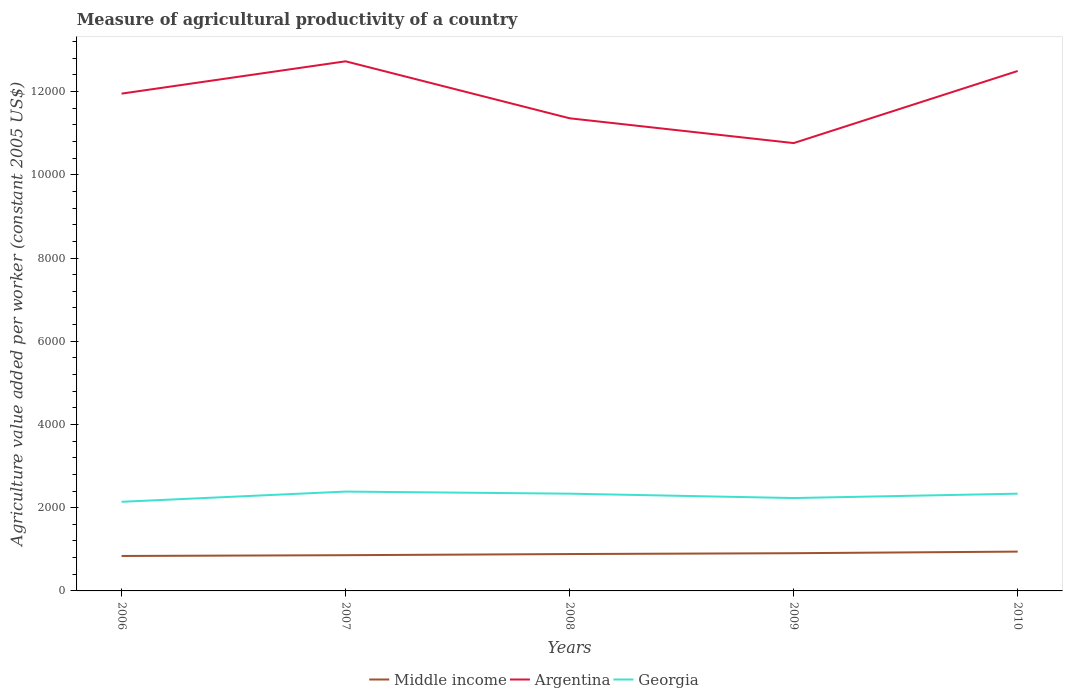How many different coloured lines are there?
Provide a succinct answer. 3. Across all years, what is the maximum measure of agricultural productivity in Argentina?
Give a very brief answer. 1.08e+04. What is the total measure of agricultural productivity in Middle income in the graph?
Offer a terse response. -58.76. What is the difference between the highest and the second highest measure of agricultural productivity in Middle income?
Ensure brevity in your answer.  104.96. How many lines are there?
Your answer should be very brief. 3. How many years are there in the graph?
Provide a short and direct response. 5. What is the difference between two consecutive major ticks on the Y-axis?
Provide a short and direct response. 2000. What is the title of the graph?
Your answer should be compact. Measure of agricultural productivity of a country. What is the label or title of the Y-axis?
Offer a terse response. Agriculture value added per worker (constant 2005 US$). What is the Agriculture value added per worker (constant 2005 US$) in Middle income in 2006?
Your response must be concise. 839.85. What is the Agriculture value added per worker (constant 2005 US$) in Argentina in 2006?
Provide a succinct answer. 1.20e+04. What is the Agriculture value added per worker (constant 2005 US$) of Georgia in 2006?
Offer a very short reply. 2142.02. What is the Agriculture value added per worker (constant 2005 US$) of Middle income in 2007?
Offer a terse response. 858.89. What is the Agriculture value added per worker (constant 2005 US$) in Argentina in 2007?
Keep it short and to the point. 1.27e+04. What is the Agriculture value added per worker (constant 2005 US$) in Georgia in 2007?
Make the answer very short. 2387.6. What is the Agriculture value added per worker (constant 2005 US$) of Middle income in 2008?
Offer a very short reply. 886.05. What is the Agriculture value added per worker (constant 2005 US$) in Argentina in 2008?
Your response must be concise. 1.14e+04. What is the Agriculture value added per worker (constant 2005 US$) of Georgia in 2008?
Provide a succinct answer. 2337.08. What is the Agriculture value added per worker (constant 2005 US$) of Middle income in 2009?
Offer a terse response. 906.34. What is the Agriculture value added per worker (constant 2005 US$) of Argentina in 2009?
Give a very brief answer. 1.08e+04. What is the Agriculture value added per worker (constant 2005 US$) of Georgia in 2009?
Provide a short and direct response. 2232.16. What is the Agriculture value added per worker (constant 2005 US$) of Middle income in 2010?
Give a very brief answer. 944.82. What is the Agriculture value added per worker (constant 2005 US$) of Argentina in 2010?
Your answer should be compact. 1.25e+04. What is the Agriculture value added per worker (constant 2005 US$) in Georgia in 2010?
Ensure brevity in your answer.  2337.06. Across all years, what is the maximum Agriculture value added per worker (constant 2005 US$) in Middle income?
Provide a short and direct response. 944.82. Across all years, what is the maximum Agriculture value added per worker (constant 2005 US$) of Argentina?
Provide a succinct answer. 1.27e+04. Across all years, what is the maximum Agriculture value added per worker (constant 2005 US$) in Georgia?
Give a very brief answer. 2387.6. Across all years, what is the minimum Agriculture value added per worker (constant 2005 US$) in Middle income?
Keep it short and to the point. 839.85. Across all years, what is the minimum Agriculture value added per worker (constant 2005 US$) in Argentina?
Ensure brevity in your answer.  1.08e+04. Across all years, what is the minimum Agriculture value added per worker (constant 2005 US$) in Georgia?
Give a very brief answer. 2142.02. What is the total Agriculture value added per worker (constant 2005 US$) in Middle income in the graph?
Your answer should be compact. 4435.94. What is the total Agriculture value added per worker (constant 2005 US$) of Argentina in the graph?
Make the answer very short. 5.93e+04. What is the total Agriculture value added per worker (constant 2005 US$) in Georgia in the graph?
Ensure brevity in your answer.  1.14e+04. What is the difference between the Agriculture value added per worker (constant 2005 US$) of Middle income in 2006 and that in 2007?
Your answer should be compact. -19.03. What is the difference between the Agriculture value added per worker (constant 2005 US$) in Argentina in 2006 and that in 2007?
Your answer should be very brief. -776.74. What is the difference between the Agriculture value added per worker (constant 2005 US$) of Georgia in 2006 and that in 2007?
Your answer should be very brief. -245.58. What is the difference between the Agriculture value added per worker (constant 2005 US$) in Middle income in 2006 and that in 2008?
Make the answer very short. -46.2. What is the difference between the Agriculture value added per worker (constant 2005 US$) in Argentina in 2006 and that in 2008?
Your response must be concise. 592.57. What is the difference between the Agriculture value added per worker (constant 2005 US$) of Georgia in 2006 and that in 2008?
Keep it short and to the point. -195.06. What is the difference between the Agriculture value added per worker (constant 2005 US$) in Middle income in 2006 and that in 2009?
Give a very brief answer. -66.48. What is the difference between the Agriculture value added per worker (constant 2005 US$) of Argentina in 2006 and that in 2009?
Keep it short and to the point. 1188.72. What is the difference between the Agriculture value added per worker (constant 2005 US$) of Georgia in 2006 and that in 2009?
Make the answer very short. -90.14. What is the difference between the Agriculture value added per worker (constant 2005 US$) of Middle income in 2006 and that in 2010?
Provide a succinct answer. -104.96. What is the difference between the Agriculture value added per worker (constant 2005 US$) in Argentina in 2006 and that in 2010?
Ensure brevity in your answer.  -544.22. What is the difference between the Agriculture value added per worker (constant 2005 US$) in Georgia in 2006 and that in 2010?
Offer a very short reply. -195.04. What is the difference between the Agriculture value added per worker (constant 2005 US$) in Middle income in 2007 and that in 2008?
Your answer should be very brief. -27.17. What is the difference between the Agriculture value added per worker (constant 2005 US$) in Argentina in 2007 and that in 2008?
Offer a very short reply. 1369.31. What is the difference between the Agriculture value added per worker (constant 2005 US$) in Georgia in 2007 and that in 2008?
Provide a succinct answer. 50.52. What is the difference between the Agriculture value added per worker (constant 2005 US$) in Middle income in 2007 and that in 2009?
Your answer should be very brief. -47.45. What is the difference between the Agriculture value added per worker (constant 2005 US$) in Argentina in 2007 and that in 2009?
Give a very brief answer. 1965.46. What is the difference between the Agriculture value added per worker (constant 2005 US$) in Georgia in 2007 and that in 2009?
Your answer should be compact. 155.44. What is the difference between the Agriculture value added per worker (constant 2005 US$) of Middle income in 2007 and that in 2010?
Keep it short and to the point. -85.93. What is the difference between the Agriculture value added per worker (constant 2005 US$) in Argentina in 2007 and that in 2010?
Your answer should be very brief. 232.52. What is the difference between the Agriculture value added per worker (constant 2005 US$) of Georgia in 2007 and that in 2010?
Offer a terse response. 50.54. What is the difference between the Agriculture value added per worker (constant 2005 US$) of Middle income in 2008 and that in 2009?
Give a very brief answer. -20.28. What is the difference between the Agriculture value added per worker (constant 2005 US$) of Argentina in 2008 and that in 2009?
Offer a terse response. 596.16. What is the difference between the Agriculture value added per worker (constant 2005 US$) in Georgia in 2008 and that in 2009?
Offer a very short reply. 104.92. What is the difference between the Agriculture value added per worker (constant 2005 US$) of Middle income in 2008 and that in 2010?
Provide a short and direct response. -58.76. What is the difference between the Agriculture value added per worker (constant 2005 US$) in Argentina in 2008 and that in 2010?
Your answer should be very brief. -1136.79. What is the difference between the Agriculture value added per worker (constant 2005 US$) of Georgia in 2008 and that in 2010?
Give a very brief answer. 0.02. What is the difference between the Agriculture value added per worker (constant 2005 US$) in Middle income in 2009 and that in 2010?
Offer a very short reply. -38.48. What is the difference between the Agriculture value added per worker (constant 2005 US$) of Argentina in 2009 and that in 2010?
Give a very brief answer. -1732.95. What is the difference between the Agriculture value added per worker (constant 2005 US$) of Georgia in 2009 and that in 2010?
Make the answer very short. -104.9. What is the difference between the Agriculture value added per worker (constant 2005 US$) of Middle income in 2006 and the Agriculture value added per worker (constant 2005 US$) of Argentina in 2007?
Your answer should be compact. -1.19e+04. What is the difference between the Agriculture value added per worker (constant 2005 US$) in Middle income in 2006 and the Agriculture value added per worker (constant 2005 US$) in Georgia in 2007?
Offer a very short reply. -1547.74. What is the difference between the Agriculture value added per worker (constant 2005 US$) in Argentina in 2006 and the Agriculture value added per worker (constant 2005 US$) in Georgia in 2007?
Ensure brevity in your answer.  9563.93. What is the difference between the Agriculture value added per worker (constant 2005 US$) in Middle income in 2006 and the Agriculture value added per worker (constant 2005 US$) in Argentina in 2008?
Give a very brief answer. -1.05e+04. What is the difference between the Agriculture value added per worker (constant 2005 US$) in Middle income in 2006 and the Agriculture value added per worker (constant 2005 US$) in Georgia in 2008?
Your answer should be very brief. -1497.22. What is the difference between the Agriculture value added per worker (constant 2005 US$) in Argentina in 2006 and the Agriculture value added per worker (constant 2005 US$) in Georgia in 2008?
Offer a terse response. 9614.45. What is the difference between the Agriculture value added per worker (constant 2005 US$) of Middle income in 2006 and the Agriculture value added per worker (constant 2005 US$) of Argentina in 2009?
Provide a succinct answer. -9922.95. What is the difference between the Agriculture value added per worker (constant 2005 US$) of Middle income in 2006 and the Agriculture value added per worker (constant 2005 US$) of Georgia in 2009?
Offer a terse response. -1392.31. What is the difference between the Agriculture value added per worker (constant 2005 US$) of Argentina in 2006 and the Agriculture value added per worker (constant 2005 US$) of Georgia in 2009?
Keep it short and to the point. 9719.37. What is the difference between the Agriculture value added per worker (constant 2005 US$) of Middle income in 2006 and the Agriculture value added per worker (constant 2005 US$) of Argentina in 2010?
Offer a terse response. -1.17e+04. What is the difference between the Agriculture value added per worker (constant 2005 US$) in Middle income in 2006 and the Agriculture value added per worker (constant 2005 US$) in Georgia in 2010?
Your answer should be very brief. -1497.2. What is the difference between the Agriculture value added per worker (constant 2005 US$) in Argentina in 2006 and the Agriculture value added per worker (constant 2005 US$) in Georgia in 2010?
Offer a terse response. 9614.47. What is the difference between the Agriculture value added per worker (constant 2005 US$) in Middle income in 2007 and the Agriculture value added per worker (constant 2005 US$) in Argentina in 2008?
Keep it short and to the point. -1.05e+04. What is the difference between the Agriculture value added per worker (constant 2005 US$) in Middle income in 2007 and the Agriculture value added per worker (constant 2005 US$) in Georgia in 2008?
Make the answer very short. -1478.19. What is the difference between the Agriculture value added per worker (constant 2005 US$) in Argentina in 2007 and the Agriculture value added per worker (constant 2005 US$) in Georgia in 2008?
Give a very brief answer. 1.04e+04. What is the difference between the Agriculture value added per worker (constant 2005 US$) in Middle income in 2007 and the Agriculture value added per worker (constant 2005 US$) in Argentina in 2009?
Ensure brevity in your answer.  -9903.91. What is the difference between the Agriculture value added per worker (constant 2005 US$) of Middle income in 2007 and the Agriculture value added per worker (constant 2005 US$) of Georgia in 2009?
Offer a terse response. -1373.27. What is the difference between the Agriculture value added per worker (constant 2005 US$) in Argentina in 2007 and the Agriculture value added per worker (constant 2005 US$) in Georgia in 2009?
Offer a terse response. 1.05e+04. What is the difference between the Agriculture value added per worker (constant 2005 US$) in Middle income in 2007 and the Agriculture value added per worker (constant 2005 US$) in Argentina in 2010?
Provide a short and direct response. -1.16e+04. What is the difference between the Agriculture value added per worker (constant 2005 US$) in Middle income in 2007 and the Agriculture value added per worker (constant 2005 US$) in Georgia in 2010?
Keep it short and to the point. -1478.17. What is the difference between the Agriculture value added per worker (constant 2005 US$) of Argentina in 2007 and the Agriculture value added per worker (constant 2005 US$) of Georgia in 2010?
Offer a very short reply. 1.04e+04. What is the difference between the Agriculture value added per worker (constant 2005 US$) in Middle income in 2008 and the Agriculture value added per worker (constant 2005 US$) in Argentina in 2009?
Offer a very short reply. -9876.75. What is the difference between the Agriculture value added per worker (constant 2005 US$) in Middle income in 2008 and the Agriculture value added per worker (constant 2005 US$) in Georgia in 2009?
Provide a short and direct response. -1346.1. What is the difference between the Agriculture value added per worker (constant 2005 US$) of Argentina in 2008 and the Agriculture value added per worker (constant 2005 US$) of Georgia in 2009?
Ensure brevity in your answer.  9126.8. What is the difference between the Agriculture value added per worker (constant 2005 US$) in Middle income in 2008 and the Agriculture value added per worker (constant 2005 US$) in Argentina in 2010?
Ensure brevity in your answer.  -1.16e+04. What is the difference between the Agriculture value added per worker (constant 2005 US$) of Middle income in 2008 and the Agriculture value added per worker (constant 2005 US$) of Georgia in 2010?
Offer a very short reply. -1451. What is the difference between the Agriculture value added per worker (constant 2005 US$) of Argentina in 2008 and the Agriculture value added per worker (constant 2005 US$) of Georgia in 2010?
Your answer should be very brief. 9021.9. What is the difference between the Agriculture value added per worker (constant 2005 US$) of Middle income in 2009 and the Agriculture value added per worker (constant 2005 US$) of Argentina in 2010?
Offer a terse response. -1.16e+04. What is the difference between the Agriculture value added per worker (constant 2005 US$) in Middle income in 2009 and the Agriculture value added per worker (constant 2005 US$) in Georgia in 2010?
Offer a terse response. -1430.72. What is the difference between the Agriculture value added per worker (constant 2005 US$) of Argentina in 2009 and the Agriculture value added per worker (constant 2005 US$) of Georgia in 2010?
Offer a terse response. 8425.74. What is the average Agriculture value added per worker (constant 2005 US$) in Middle income per year?
Give a very brief answer. 887.19. What is the average Agriculture value added per worker (constant 2005 US$) of Argentina per year?
Provide a succinct answer. 1.19e+04. What is the average Agriculture value added per worker (constant 2005 US$) in Georgia per year?
Ensure brevity in your answer.  2287.18. In the year 2006, what is the difference between the Agriculture value added per worker (constant 2005 US$) of Middle income and Agriculture value added per worker (constant 2005 US$) of Argentina?
Give a very brief answer. -1.11e+04. In the year 2006, what is the difference between the Agriculture value added per worker (constant 2005 US$) in Middle income and Agriculture value added per worker (constant 2005 US$) in Georgia?
Your response must be concise. -1302.17. In the year 2006, what is the difference between the Agriculture value added per worker (constant 2005 US$) in Argentina and Agriculture value added per worker (constant 2005 US$) in Georgia?
Your answer should be very brief. 9809.5. In the year 2007, what is the difference between the Agriculture value added per worker (constant 2005 US$) in Middle income and Agriculture value added per worker (constant 2005 US$) in Argentina?
Ensure brevity in your answer.  -1.19e+04. In the year 2007, what is the difference between the Agriculture value added per worker (constant 2005 US$) of Middle income and Agriculture value added per worker (constant 2005 US$) of Georgia?
Make the answer very short. -1528.71. In the year 2007, what is the difference between the Agriculture value added per worker (constant 2005 US$) of Argentina and Agriculture value added per worker (constant 2005 US$) of Georgia?
Offer a very short reply. 1.03e+04. In the year 2008, what is the difference between the Agriculture value added per worker (constant 2005 US$) of Middle income and Agriculture value added per worker (constant 2005 US$) of Argentina?
Give a very brief answer. -1.05e+04. In the year 2008, what is the difference between the Agriculture value added per worker (constant 2005 US$) in Middle income and Agriculture value added per worker (constant 2005 US$) in Georgia?
Provide a succinct answer. -1451.02. In the year 2008, what is the difference between the Agriculture value added per worker (constant 2005 US$) of Argentina and Agriculture value added per worker (constant 2005 US$) of Georgia?
Provide a short and direct response. 9021.88. In the year 2009, what is the difference between the Agriculture value added per worker (constant 2005 US$) in Middle income and Agriculture value added per worker (constant 2005 US$) in Argentina?
Ensure brevity in your answer.  -9856.46. In the year 2009, what is the difference between the Agriculture value added per worker (constant 2005 US$) in Middle income and Agriculture value added per worker (constant 2005 US$) in Georgia?
Provide a succinct answer. -1325.82. In the year 2009, what is the difference between the Agriculture value added per worker (constant 2005 US$) of Argentina and Agriculture value added per worker (constant 2005 US$) of Georgia?
Your answer should be very brief. 8530.64. In the year 2010, what is the difference between the Agriculture value added per worker (constant 2005 US$) in Middle income and Agriculture value added per worker (constant 2005 US$) in Argentina?
Offer a terse response. -1.16e+04. In the year 2010, what is the difference between the Agriculture value added per worker (constant 2005 US$) of Middle income and Agriculture value added per worker (constant 2005 US$) of Georgia?
Offer a terse response. -1392.24. In the year 2010, what is the difference between the Agriculture value added per worker (constant 2005 US$) of Argentina and Agriculture value added per worker (constant 2005 US$) of Georgia?
Ensure brevity in your answer.  1.02e+04. What is the ratio of the Agriculture value added per worker (constant 2005 US$) in Middle income in 2006 to that in 2007?
Keep it short and to the point. 0.98. What is the ratio of the Agriculture value added per worker (constant 2005 US$) in Argentina in 2006 to that in 2007?
Provide a short and direct response. 0.94. What is the ratio of the Agriculture value added per worker (constant 2005 US$) of Georgia in 2006 to that in 2007?
Your response must be concise. 0.9. What is the ratio of the Agriculture value added per worker (constant 2005 US$) in Middle income in 2006 to that in 2008?
Offer a very short reply. 0.95. What is the ratio of the Agriculture value added per worker (constant 2005 US$) in Argentina in 2006 to that in 2008?
Offer a terse response. 1.05. What is the ratio of the Agriculture value added per worker (constant 2005 US$) in Georgia in 2006 to that in 2008?
Your response must be concise. 0.92. What is the ratio of the Agriculture value added per worker (constant 2005 US$) of Middle income in 2006 to that in 2009?
Your answer should be very brief. 0.93. What is the ratio of the Agriculture value added per worker (constant 2005 US$) of Argentina in 2006 to that in 2009?
Make the answer very short. 1.11. What is the ratio of the Agriculture value added per worker (constant 2005 US$) of Georgia in 2006 to that in 2009?
Offer a terse response. 0.96. What is the ratio of the Agriculture value added per worker (constant 2005 US$) of Middle income in 2006 to that in 2010?
Your answer should be very brief. 0.89. What is the ratio of the Agriculture value added per worker (constant 2005 US$) of Argentina in 2006 to that in 2010?
Make the answer very short. 0.96. What is the ratio of the Agriculture value added per worker (constant 2005 US$) of Georgia in 2006 to that in 2010?
Offer a very short reply. 0.92. What is the ratio of the Agriculture value added per worker (constant 2005 US$) in Middle income in 2007 to that in 2008?
Your response must be concise. 0.97. What is the ratio of the Agriculture value added per worker (constant 2005 US$) of Argentina in 2007 to that in 2008?
Give a very brief answer. 1.12. What is the ratio of the Agriculture value added per worker (constant 2005 US$) of Georgia in 2007 to that in 2008?
Your answer should be compact. 1.02. What is the ratio of the Agriculture value added per worker (constant 2005 US$) in Middle income in 2007 to that in 2009?
Keep it short and to the point. 0.95. What is the ratio of the Agriculture value added per worker (constant 2005 US$) of Argentina in 2007 to that in 2009?
Keep it short and to the point. 1.18. What is the ratio of the Agriculture value added per worker (constant 2005 US$) in Georgia in 2007 to that in 2009?
Your answer should be very brief. 1.07. What is the ratio of the Agriculture value added per worker (constant 2005 US$) of Middle income in 2007 to that in 2010?
Offer a very short reply. 0.91. What is the ratio of the Agriculture value added per worker (constant 2005 US$) of Argentina in 2007 to that in 2010?
Make the answer very short. 1.02. What is the ratio of the Agriculture value added per worker (constant 2005 US$) of Georgia in 2007 to that in 2010?
Your answer should be compact. 1.02. What is the ratio of the Agriculture value added per worker (constant 2005 US$) of Middle income in 2008 to that in 2009?
Provide a succinct answer. 0.98. What is the ratio of the Agriculture value added per worker (constant 2005 US$) of Argentina in 2008 to that in 2009?
Your answer should be very brief. 1.06. What is the ratio of the Agriculture value added per worker (constant 2005 US$) of Georgia in 2008 to that in 2009?
Keep it short and to the point. 1.05. What is the ratio of the Agriculture value added per worker (constant 2005 US$) in Middle income in 2008 to that in 2010?
Keep it short and to the point. 0.94. What is the ratio of the Agriculture value added per worker (constant 2005 US$) of Argentina in 2008 to that in 2010?
Offer a very short reply. 0.91. What is the ratio of the Agriculture value added per worker (constant 2005 US$) of Middle income in 2009 to that in 2010?
Keep it short and to the point. 0.96. What is the ratio of the Agriculture value added per worker (constant 2005 US$) in Argentina in 2009 to that in 2010?
Provide a succinct answer. 0.86. What is the ratio of the Agriculture value added per worker (constant 2005 US$) of Georgia in 2009 to that in 2010?
Keep it short and to the point. 0.96. What is the difference between the highest and the second highest Agriculture value added per worker (constant 2005 US$) of Middle income?
Keep it short and to the point. 38.48. What is the difference between the highest and the second highest Agriculture value added per worker (constant 2005 US$) of Argentina?
Your answer should be compact. 232.52. What is the difference between the highest and the second highest Agriculture value added per worker (constant 2005 US$) of Georgia?
Offer a very short reply. 50.52. What is the difference between the highest and the lowest Agriculture value added per worker (constant 2005 US$) in Middle income?
Ensure brevity in your answer.  104.96. What is the difference between the highest and the lowest Agriculture value added per worker (constant 2005 US$) of Argentina?
Your response must be concise. 1965.46. What is the difference between the highest and the lowest Agriculture value added per worker (constant 2005 US$) in Georgia?
Ensure brevity in your answer.  245.58. 